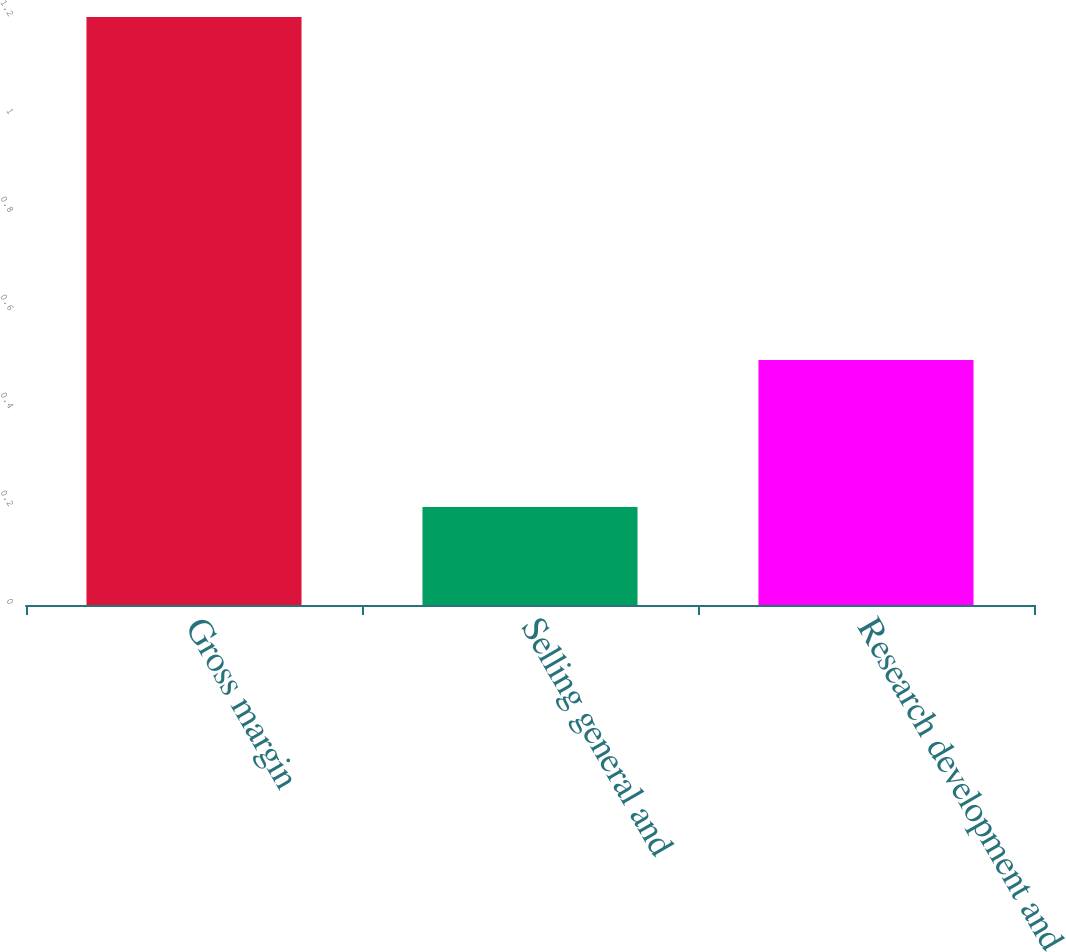Convert chart. <chart><loc_0><loc_0><loc_500><loc_500><bar_chart><fcel>Gross margin<fcel>Selling general and<fcel>Research development and<nl><fcel>1.2<fcel>0.2<fcel>0.5<nl></chart> 